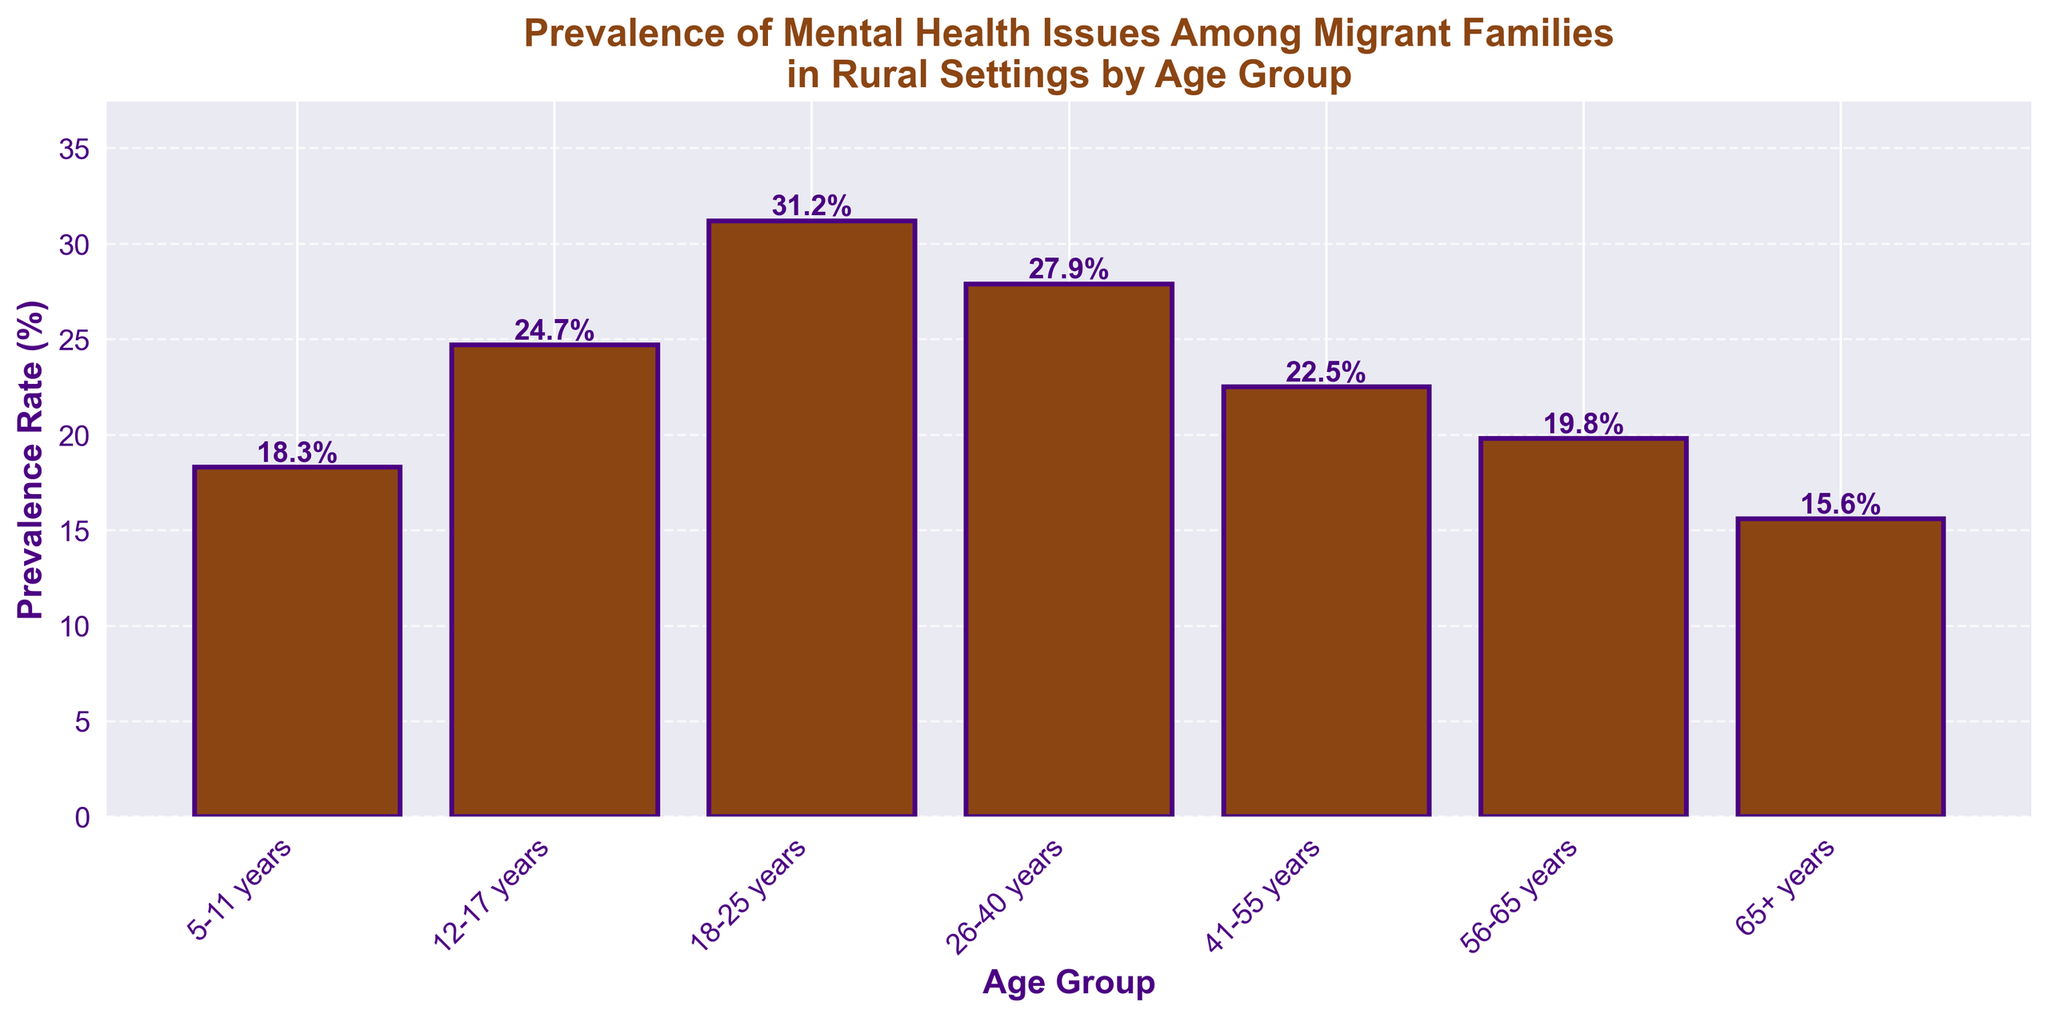Which age group has the highest prevalence rate of mental health issues? The bar for the 18-25 years age group is the tallest, indicating it has the highest prevalence rate of mental health issues.
Answer: 18-25 years Which age group has the lowest prevalence rate of mental health issues? The bar for the 65+ years age group is the shortest, indicating it has the lowest prevalence rate of mental health issues.
Answer: 65+ years What is the difference in prevalence rate between the 18-25 years and the 65+ years age groups? The prevalence rate for the 18-25 years age group is 31.2%, and for the 65+ years age group is 15.6%. The difference is 31.2% - 15.6%.
Answer: 15.6% What is the sum of the prevalence rates for the 12-17 years and 41-55 years age groups? The prevalence rate for the 12-17 years age group is 24.7%, and for the 41-55 years age group is 22.5%. The sum is 24.7% + 22.5%.
Answer: 47.2% Which age group has a prevalence rate closest to 20%? The prevalence rate for the 56-65 years age group is 19.8%, which is closest to 20%.
Answer: 56-65 years By how many percentage points is the prevalence rate of the 26-40 years age group higher than that of the 5-11 years age group? The prevalence rate for the 26-40 years age group is 27.9%, and for the 5-11 years age group is 18.3%. The difference is 27.9% - 18.3%.
Answer: 9.6 percentage points Rank the age groups from highest to lowest prevalence rate. The prevalence rates in descending order: 18-25 years (31.2%), 26-40 years (27.9%), 12-17 years (24.7%), 41-55 years (22.5%), 56-65 years (19.8%), 5-11 years (18.3%), 65+ years (15.6%).
Answer: 18-25 years, 26-40 years, 12-17 years, 41-55 years, 56-65 years, 5-11 years, 65+ years 